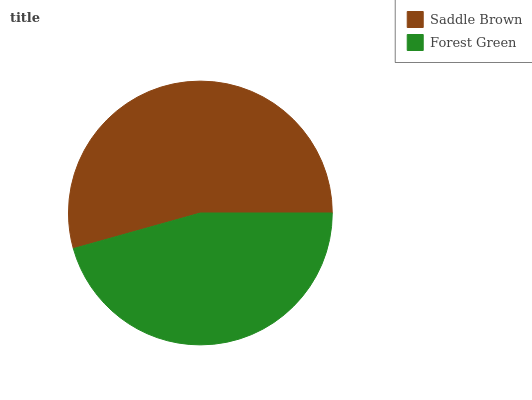Is Forest Green the minimum?
Answer yes or no. Yes. Is Saddle Brown the maximum?
Answer yes or no. Yes. Is Forest Green the maximum?
Answer yes or no. No. Is Saddle Brown greater than Forest Green?
Answer yes or no. Yes. Is Forest Green less than Saddle Brown?
Answer yes or no. Yes. Is Forest Green greater than Saddle Brown?
Answer yes or no. No. Is Saddle Brown less than Forest Green?
Answer yes or no. No. Is Saddle Brown the high median?
Answer yes or no. Yes. Is Forest Green the low median?
Answer yes or no. Yes. Is Forest Green the high median?
Answer yes or no. No. Is Saddle Brown the low median?
Answer yes or no. No. 